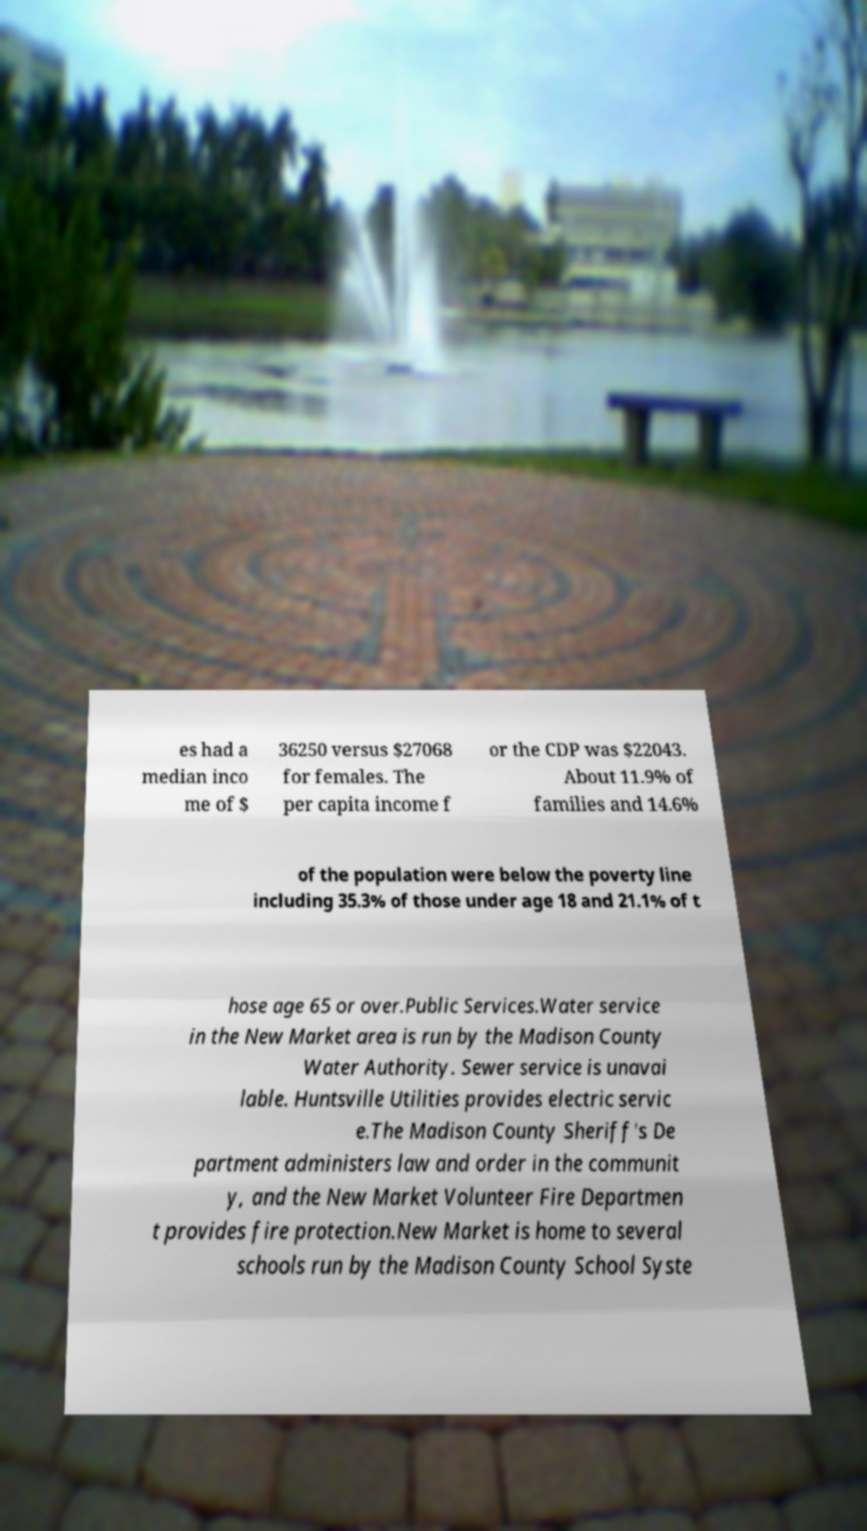Please read and relay the text visible in this image. What does it say? es had a median inco me of $ 36250 versus $27068 for females. The per capita income f or the CDP was $22043. About 11.9% of families and 14.6% of the population were below the poverty line including 35.3% of those under age 18 and 21.1% of t hose age 65 or over.Public Services.Water service in the New Market area is run by the Madison County Water Authority. Sewer service is unavai lable. Huntsville Utilities provides electric servic e.The Madison County Sheriff's De partment administers law and order in the communit y, and the New Market Volunteer Fire Departmen t provides fire protection.New Market is home to several schools run by the Madison County School Syste 